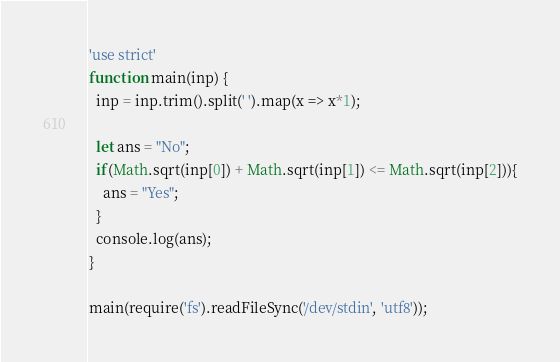<code> <loc_0><loc_0><loc_500><loc_500><_JavaScript_>'use strict'
function main(inp) {
  inp = inp.trim().split(' ').map(x => x*1);
  
  let ans = "No";
  if(Math.sqrt(inp[0]) + Math.sqrt(inp[1]) <= Math.sqrt(inp[2])){
	ans = "Yes";
  }
  console.log(ans);
}

main(require('fs').readFileSync('/dev/stdin', 'utf8'));
</code> 